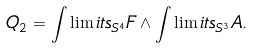Convert formula to latex. <formula><loc_0><loc_0><loc_500><loc_500>Q _ { 2 } = \int \lim i t s _ { S ^ { 4 } } F \wedge \int \lim i t s _ { S ^ { 3 } } A .</formula> 